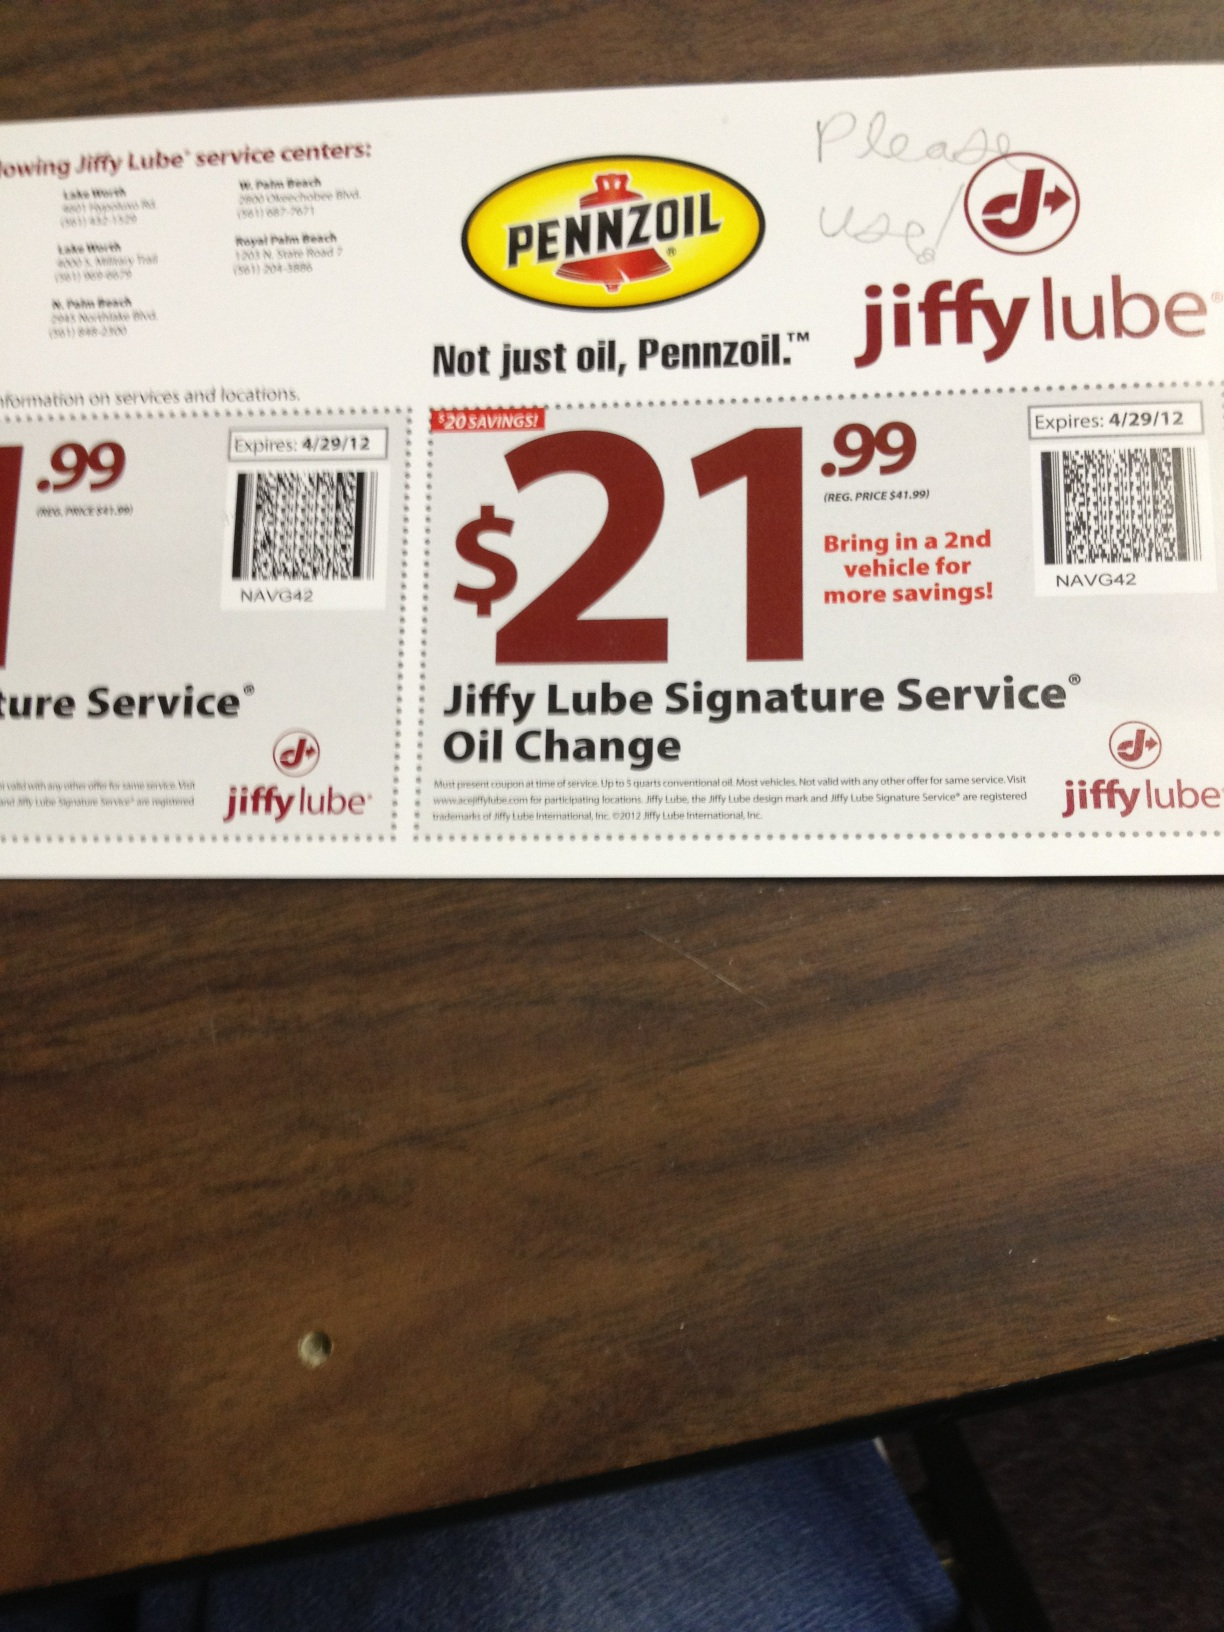Who can benefit the most from this coupon? Vehicle owners looking for an affordable and comprehensive oil change service can benefit the most from this coupon. It's particularly advantageous for those who manage multiple vehicles, as it offers further savings for an additional vehicle. 